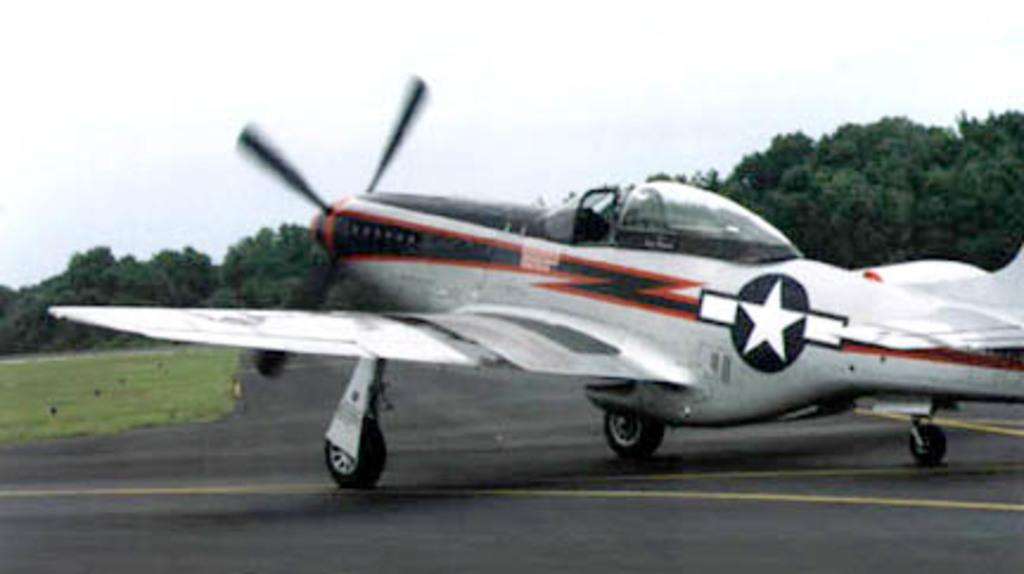What type of aircraft is in the image? There is a white-colored aircraft in the image. Can you describe any markings or logos on the aircraft? The aircraft has a logo on it. What color are the lines on the road in the image? The lines on the road are yellow-colored. What type of vegetation is visible in the image? Grass is visible in the image. What can be seen in the background of the image? There are trees in the background of the image. What type of cough medicine is being advertised on the aircraft's logo? There is no cough medicine or advertisement mentioned in the image; the aircraft has a logo, but its content is not specified. 